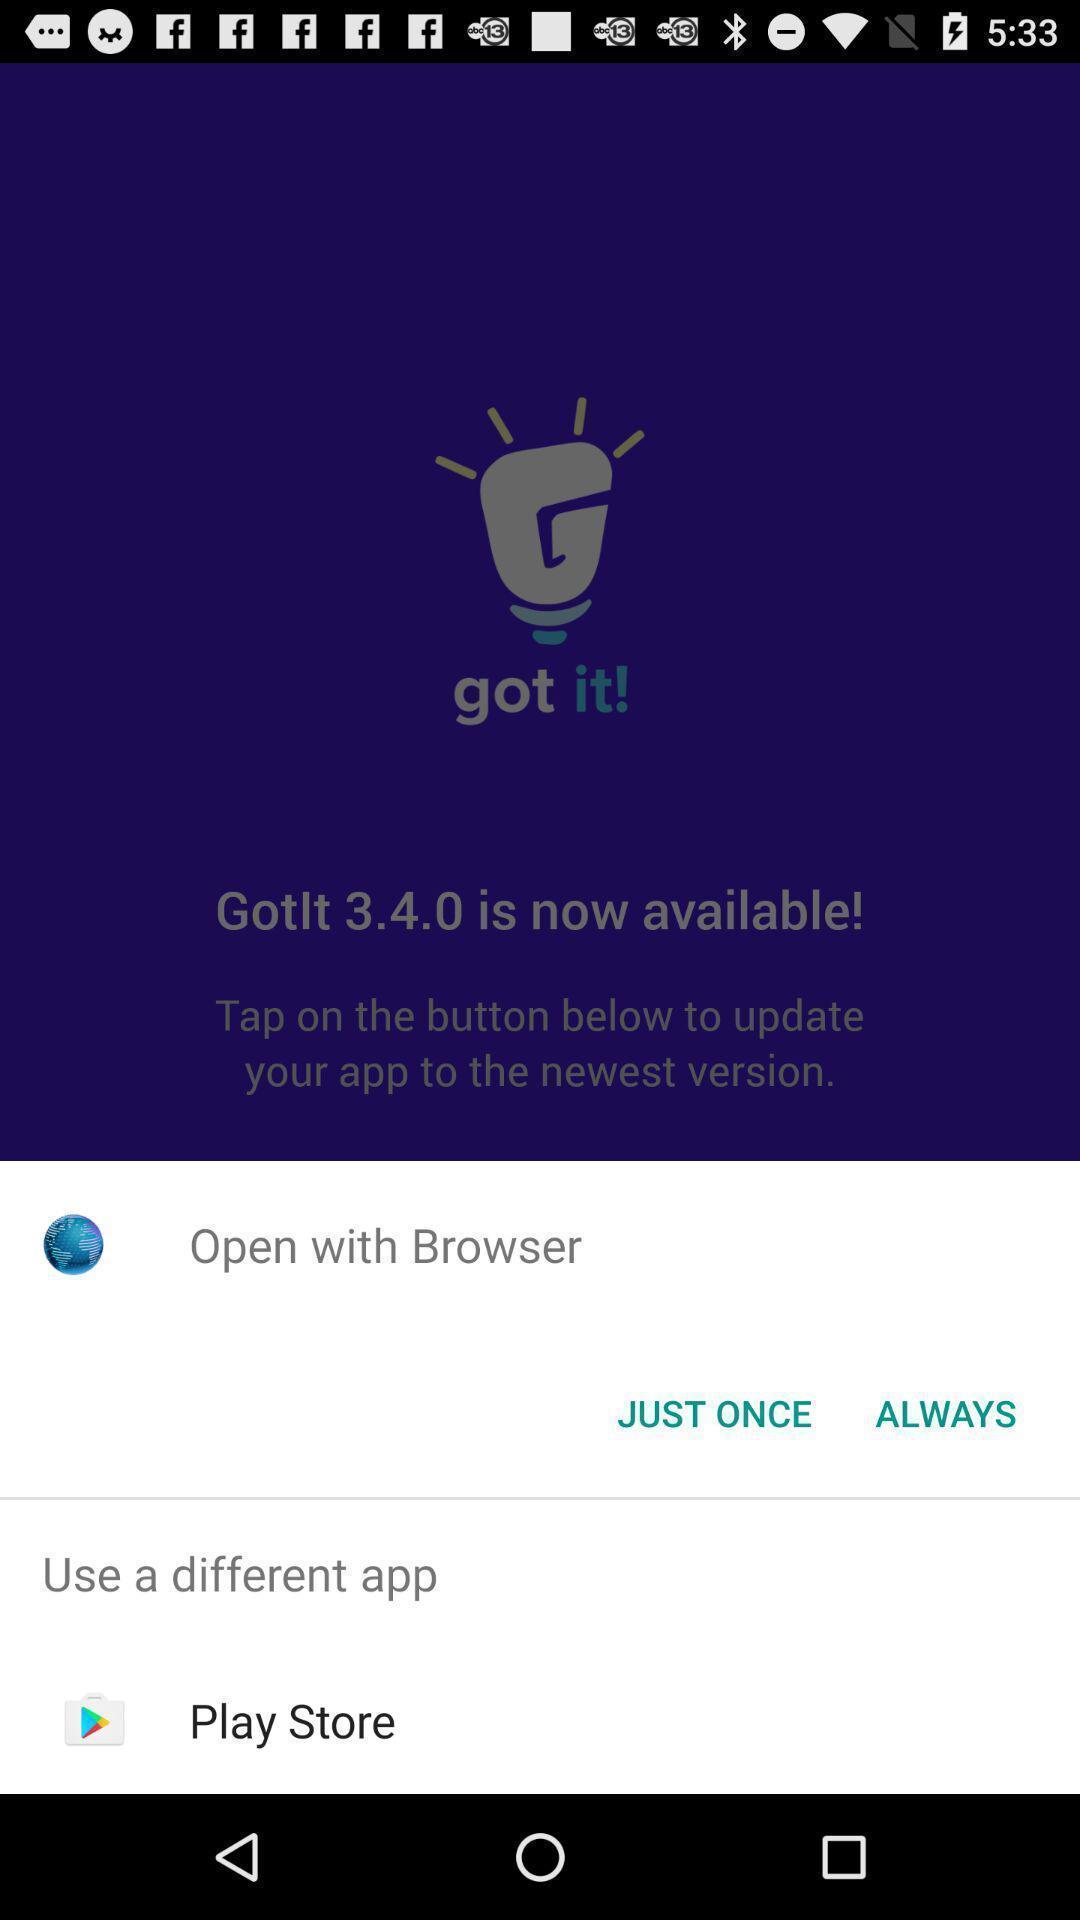Provide a description of this screenshot. Pop-up displays to open an app. 